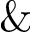<formula> <loc_0><loc_0><loc_500><loc_500>\&</formula> 